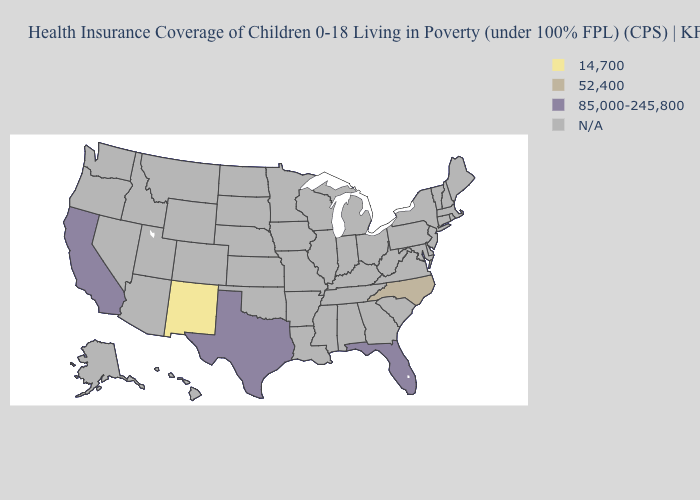Name the states that have a value in the range N/A?
Keep it brief. Alabama, Alaska, Arizona, Arkansas, Colorado, Connecticut, Delaware, Georgia, Hawaii, Idaho, Illinois, Indiana, Iowa, Kansas, Kentucky, Louisiana, Maine, Maryland, Massachusetts, Michigan, Minnesota, Mississippi, Missouri, Montana, Nebraska, Nevada, New Hampshire, New Jersey, New York, North Dakota, Ohio, Oklahoma, Oregon, Pennsylvania, Rhode Island, South Carolina, South Dakota, Tennessee, Utah, Vermont, Virginia, Washington, West Virginia, Wisconsin, Wyoming. What is the value of New Hampshire?
Give a very brief answer. N/A. What is the lowest value in states that border South Carolina?
Answer briefly. 52,400. What is the value of Nevada?
Keep it brief. N/A. Name the states that have a value in the range 52,400?
Keep it brief. North Carolina. What is the value of Kansas?
Be succinct. N/A. Which states have the lowest value in the South?
Write a very short answer. North Carolina. Does the map have missing data?
Concise answer only. Yes. What is the value of Missouri?
Write a very short answer. N/A. Which states have the lowest value in the USA?
Keep it brief. New Mexico. Does Florida have the highest value in the South?
Short answer required. Yes. Name the states that have a value in the range N/A?
Give a very brief answer. Alabama, Alaska, Arizona, Arkansas, Colorado, Connecticut, Delaware, Georgia, Hawaii, Idaho, Illinois, Indiana, Iowa, Kansas, Kentucky, Louisiana, Maine, Maryland, Massachusetts, Michigan, Minnesota, Mississippi, Missouri, Montana, Nebraska, Nevada, New Hampshire, New Jersey, New York, North Dakota, Ohio, Oklahoma, Oregon, Pennsylvania, Rhode Island, South Carolina, South Dakota, Tennessee, Utah, Vermont, Virginia, Washington, West Virginia, Wisconsin, Wyoming. 